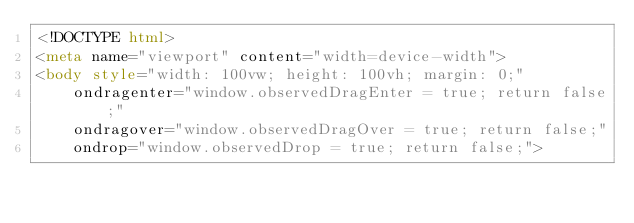<code> <loc_0><loc_0><loc_500><loc_500><_HTML_><!DOCTYPE html>
<meta name="viewport" content="width=device-width">
<body style="width: 100vw; height: 100vh; margin: 0;"
    ondragenter="window.observedDragEnter = true; return false;"
    ondragover="window.observedDragOver = true; return false;"
    ondrop="window.observedDrop = true; return false;">
</code> 